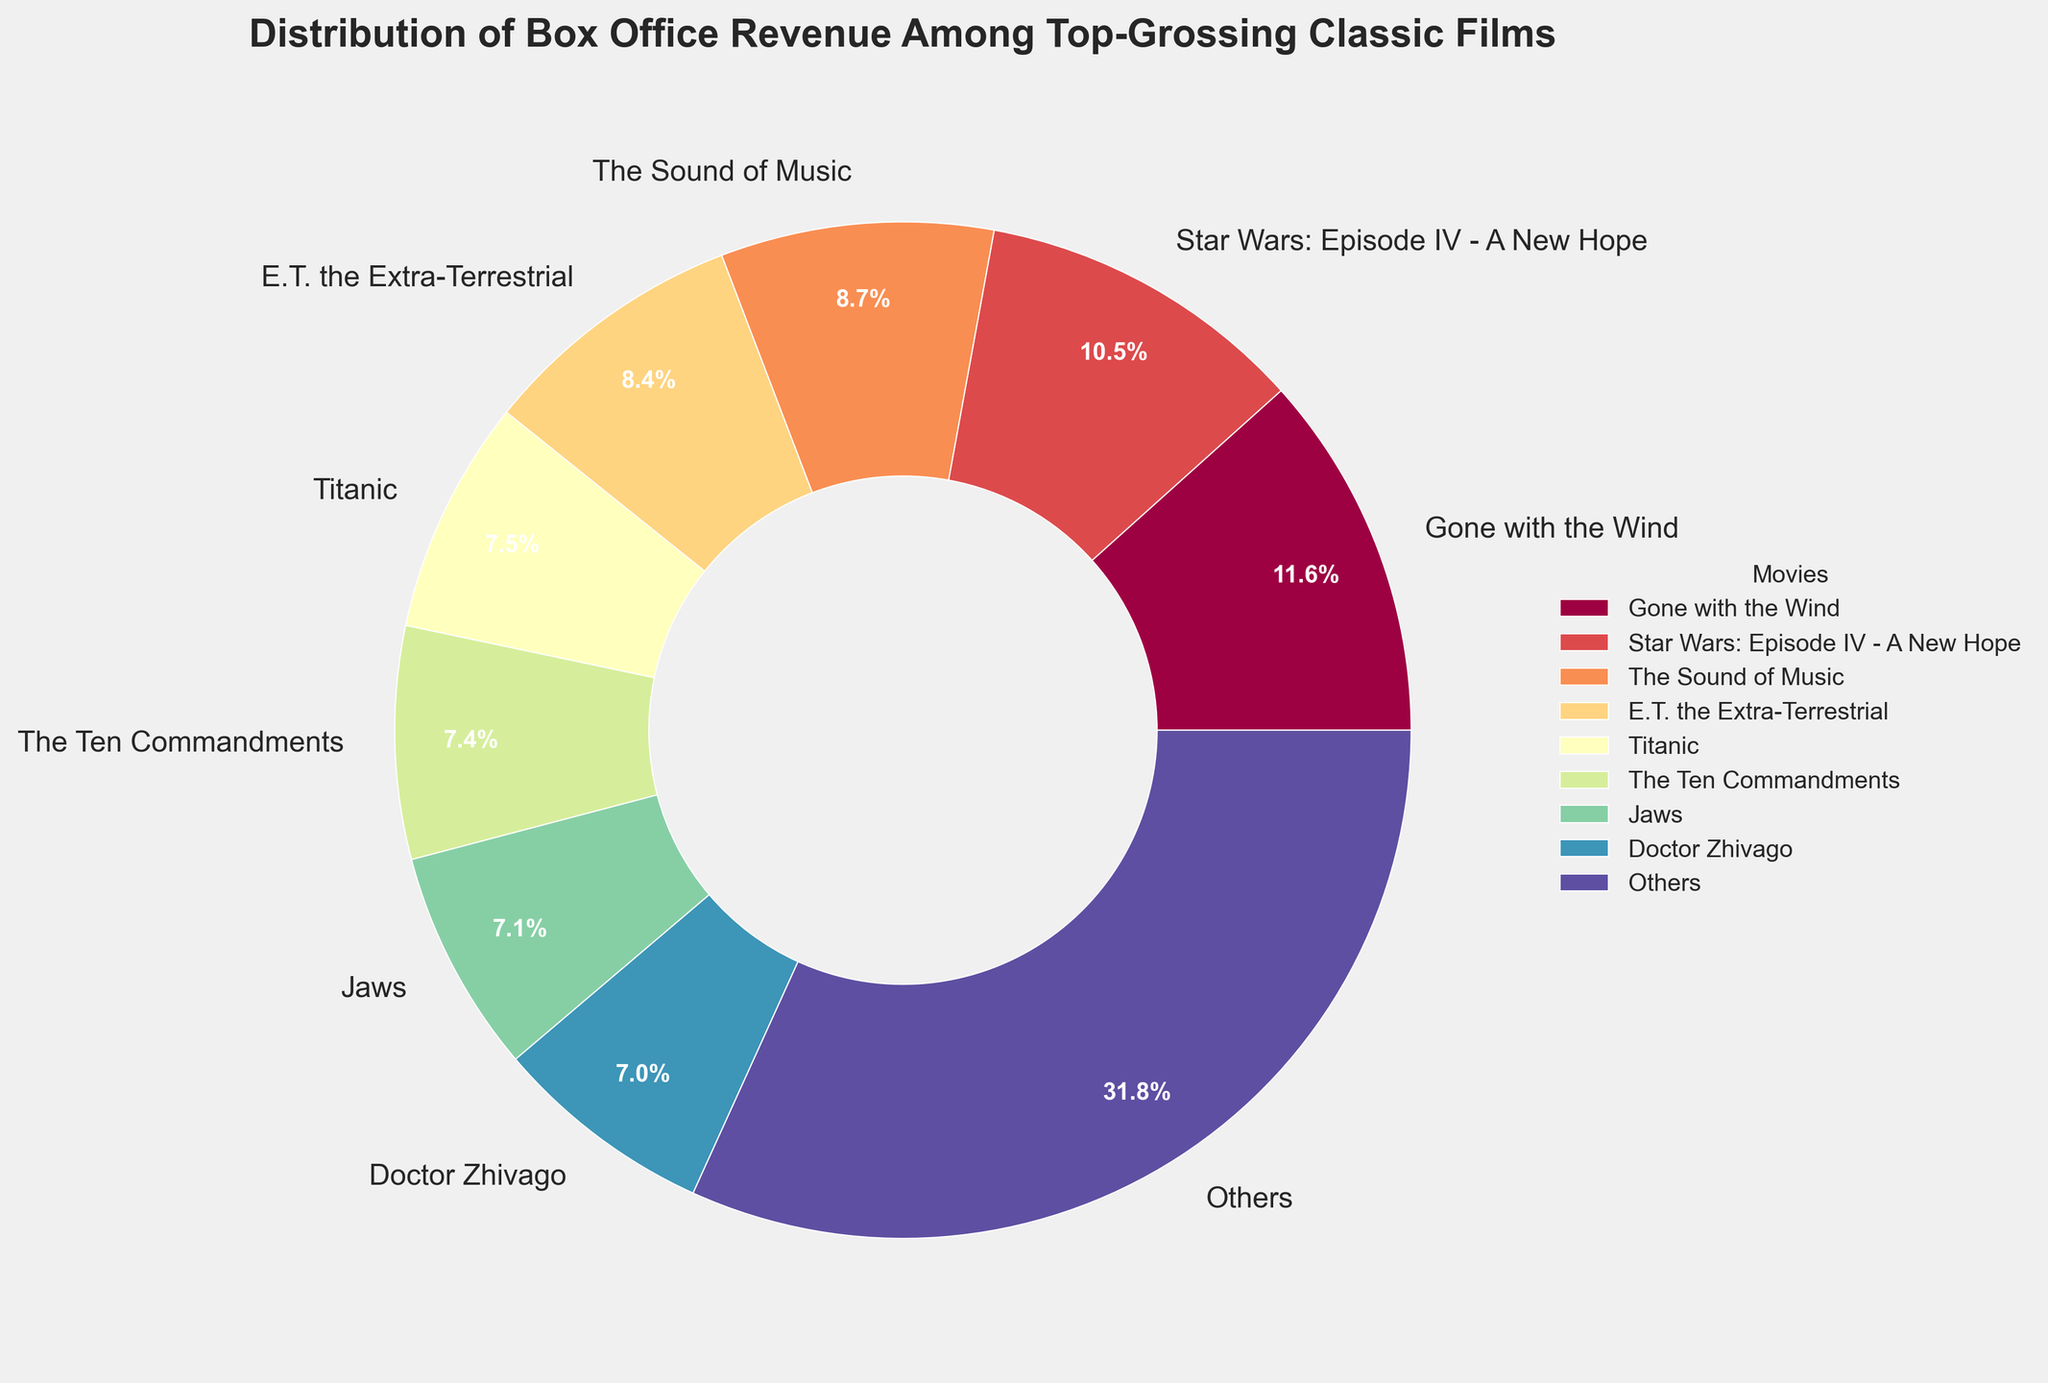Which movie has the highest adjusted box office revenue? The pie chart shows the percentage distribution of adjusted box office revenue. The largest wedge corresponds to "Gone with the Wind."
Answer: Gone with the Wind What percentage of the total revenue is generated by "Star Wars: Episode IV - A New Hope"? According to the pie chart, the segment for "Star Wars: Episode IV - A New Hope" is labeled with its percentage.
Answer: 17.7% Which movies generate more than 10% of the total revenue? The pie chart segments for "Gone with the Wind," "Star Wars: Episode IV - A New Hope," "The Sound of Music," and "E.T. the Extra-Terrestrial" each show percentages above 10%.
Answer: Gone with the Wind, Star Wars: Episode IV - A New Hope, The Sound of Music, E.T. the Extra-Terrestrial Which movie has the smallest percentage within the top eight and what is it? Among the top eight movies, the smallest wedge corresponds to "Doctor Zhivago," and the percentage is labeled.
Answer: Doctor Zhivago, 4.1% How much revenue contribution is represented by movies not in the top eight? The pie chart contains a segment labeled "Others," which represents the revenue for the remaining movies not in the top eight.
Answer: 19.0% Compare the combined revenue percentage of the top two movies with the next two movies. The top two movies "Gone with the Wind" and "Star Wars: Episode IV - A New Hope" together contribute 19.7% + 17.7% = 37.4%, while "The Sound of Music" and "E.T. the Extra-Terrestrial" together contribute 14.6% + 14.2% = 28.8%.
Answer: Combined revenue percentage of top two movies is higher What is the color of the wedge representing "Jaws"? Identify the wedge in the pie chart labeled "Jaws" and describe its color.
Answer: Green What is the difference in revenue percentage between "Titanic" and "The Ten Commandments"? According to the pie chart, "Titanic" is labeled with a percentage of 12.5% and "The Ten Commandments" with 12.4%. The difference is 12.5% - 12.4%.
Answer: 0.1% What movie's revenue is represented by the blue wedge? Locate the blue wedge in the pie chart and read the label associated with it.
Answer: The Sound of Music 